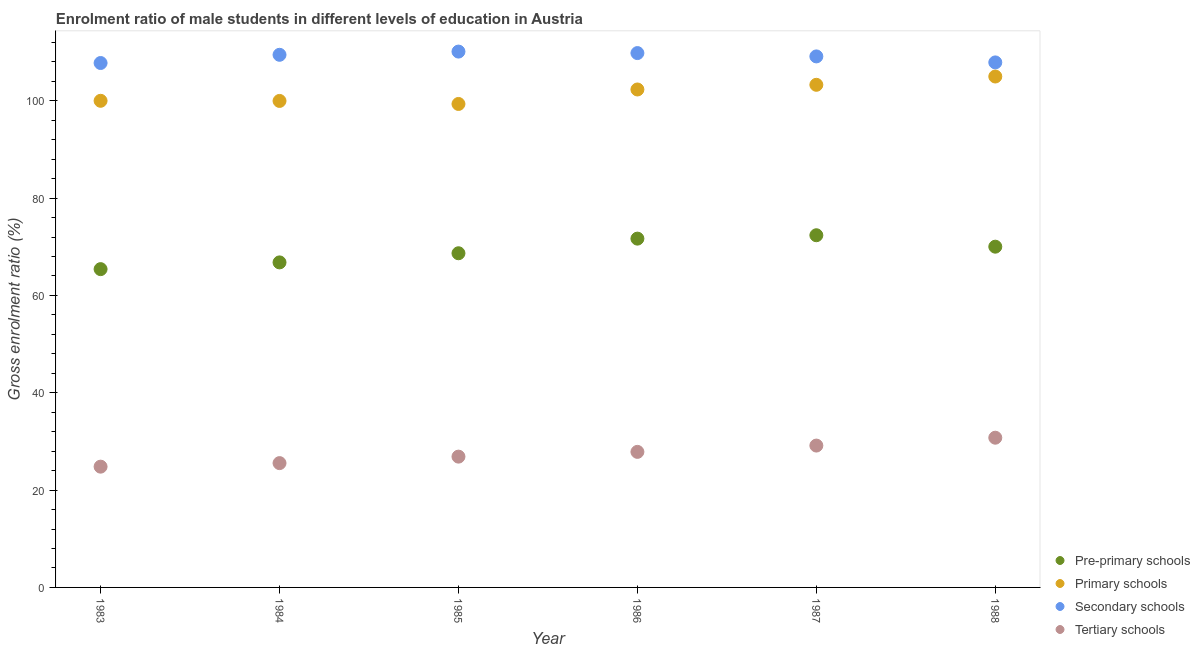What is the gross enrolment ratio(female) in primary schools in 1983?
Make the answer very short. 100. Across all years, what is the maximum gross enrolment ratio(female) in tertiary schools?
Offer a terse response. 30.77. Across all years, what is the minimum gross enrolment ratio(female) in secondary schools?
Your answer should be very brief. 107.77. In which year was the gross enrolment ratio(female) in tertiary schools maximum?
Make the answer very short. 1988. What is the total gross enrolment ratio(female) in tertiary schools in the graph?
Your answer should be very brief. 165.02. What is the difference between the gross enrolment ratio(female) in tertiary schools in 1984 and that in 1986?
Keep it short and to the point. -2.31. What is the difference between the gross enrolment ratio(female) in secondary schools in 1987 and the gross enrolment ratio(female) in primary schools in 1984?
Your response must be concise. 9.15. What is the average gross enrolment ratio(female) in secondary schools per year?
Your answer should be very brief. 109.03. In the year 1983, what is the difference between the gross enrolment ratio(female) in tertiary schools and gross enrolment ratio(female) in primary schools?
Your answer should be very brief. -75.18. In how many years, is the gross enrolment ratio(female) in pre-primary schools greater than 56 %?
Your response must be concise. 6. What is the ratio of the gross enrolment ratio(female) in primary schools in 1986 to that in 1987?
Your answer should be compact. 0.99. What is the difference between the highest and the second highest gross enrolment ratio(female) in primary schools?
Your answer should be compact. 1.7. What is the difference between the highest and the lowest gross enrolment ratio(female) in tertiary schools?
Keep it short and to the point. 5.95. Is the sum of the gross enrolment ratio(female) in primary schools in 1983 and 1988 greater than the maximum gross enrolment ratio(female) in tertiary schools across all years?
Your answer should be compact. Yes. Is it the case that in every year, the sum of the gross enrolment ratio(female) in pre-primary schools and gross enrolment ratio(female) in primary schools is greater than the gross enrolment ratio(female) in secondary schools?
Make the answer very short. Yes. Is the gross enrolment ratio(female) in pre-primary schools strictly less than the gross enrolment ratio(female) in secondary schools over the years?
Your answer should be very brief. Yes. How many years are there in the graph?
Your response must be concise. 6. Are the values on the major ticks of Y-axis written in scientific E-notation?
Offer a very short reply. No. Does the graph contain grids?
Give a very brief answer. No. How many legend labels are there?
Your response must be concise. 4. How are the legend labels stacked?
Offer a terse response. Vertical. What is the title of the graph?
Provide a short and direct response. Enrolment ratio of male students in different levels of education in Austria. What is the label or title of the X-axis?
Offer a very short reply. Year. What is the Gross enrolment ratio (%) in Pre-primary schools in 1983?
Provide a short and direct response. 65.41. What is the Gross enrolment ratio (%) in Primary schools in 1983?
Make the answer very short. 100. What is the Gross enrolment ratio (%) in Secondary schools in 1983?
Provide a short and direct response. 107.77. What is the Gross enrolment ratio (%) in Tertiary schools in 1983?
Your response must be concise. 24.82. What is the Gross enrolment ratio (%) in Pre-primary schools in 1984?
Your answer should be very brief. 66.79. What is the Gross enrolment ratio (%) of Primary schools in 1984?
Your answer should be very brief. 99.97. What is the Gross enrolment ratio (%) of Secondary schools in 1984?
Your answer should be very brief. 109.45. What is the Gross enrolment ratio (%) in Tertiary schools in 1984?
Ensure brevity in your answer.  25.55. What is the Gross enrolment ratio (%) in Pre-primary schools in 1985?
Offer a very short reply. 68.67. What is the Gross enrolment ratio (%) in Primary schools in 1985?
Provide a succinct answer. 99.35. What is the Gross enrolment ratio (%) of Secondary schools in 1985?
Keep it short and to the point. 110.12. What is the Gross enrolment ratio (%) in Tertiary schools in 1985?
Make the answer very short. 26.88. What is the Gross enrolment ratio (%) of Pre-primary schools in 1986?
Make the answer very short. 71.68. What is the Gross enrolment ratio (%) in Primary schools in 1986?
Give a very brief answer. 102.33. What is the Gross enrolment ratio (%) in Secondary schools in 1986?
Offer a very short reply. 109.81. What is the Gross enrolment ratio (%) of Tertiary schools in 1986?
Ensure brevity in your answer.  27.86. What is the Gross enrolment ratio (%) in Pre-primary schools in 1987?
Give a very brief answer. 72.37. What is the Gross enrolment ratio (%) of Primary schools in 1987?
Your response must be concise. 103.29. What is the Gross enrolment ratio (%) of Secondary schools in 1987?
Your response must be concise. 109.12. What is the Gross enrolment ratio (%) in Tertiary schools in 1987?
Offer a very short reply. 29.15. What is the Gross enrolment ratio (%) of Pre-primary schools in 1988?
Provide a short and direct response. 70.02. What is the Gross enrolment ratio (%) in Primary schools in 1988?
Ensure brevity in your answer.  104.99. What is the Gross enrolment ratio (%) in Secondary schools in 1988?
Your answer should be very brief. 107.89. What is the Gross enrolment ratio (%) of Tertiary schools in 1988?
Offer a terse response. 30.77. Across all years, what is the maximum Gross enrolment ratio (%) in Pre-primary schools?
Keep it short and to the point. 72.37. Across all years, what is the maximum Gross enrolment ratio (%) of Primary schools?
Offer a very short reply. 104.99. Across all years, what is the maximum Gross enrolment ratio (%) of Secondary schools?
Your answer should be compact. 110.12. Across all years, what is the maximum Gross enrolment ratio (%) of Tertiary schools?
Make the answer very short. 30.77. Across all years, what is the minimum Gross enrolment ratio (%) of Pre-primary schools?
Make the answer very short. 65.41. Across all years, what is the minimum Gross enrolment ratio (%) of Primary schools?
Your answer should be compact. 99.35. Across all years, what is the minimum Gross enrolment ratio (%) of Secondary schools?
Provide a short and direct response. 107.77. Across all years, what is the minimum Gross enrolment ratio (%) of Tertiary schools?
Provide a succinct answer. 24.82. What is the total Gross enrolment ratio (%) in Pre-primary schools in the graph?
Your answer should be compact. 414.95. What is the total Gross enrolment ratio (%) of Primary schools in the graph?
Keep it short and to the point. 609.93. What is the total Gross enrolment ratio (%) in Secondary schools in the graph?
Offer a very short reply. 654.16. What is the total Gross enrolment ratio (%) in Tertiary schools in the graph?
Make the answer very short. 165.02. What is the difference between the Gross enrolment ratio (%) of Pre-primary schools in 1983 and that in 1984?
Ensure brevity in your answer.  -1.39. What is the difference between the Gross enrolment ratio (%) in Primary schools in 1983 and that in 1984?
Ensure brevity in your answer.  0.03. What is the difference between the Gross enrolment ratio (%) in Secondary schools in 1983 and that in 1984?
Your answer should be compact. -1.69. What is the difference between the Gross enrolment ratio (%) of Tertiary schools in 1983 and that in 1984?
Provide a succinct answer. -0.73. What is the difference between the Gross enrolment ratio (%) in Pre-primary schools in 1983 and that in 1985?
Provide a short and direct response. -3.26. What is the difference between the Gross enrolment ratio (%) in Primary schools in 1983 and that in 1985?
Your answer should be very brief. 0.65. What is the difference between the Gross enrolment ratio (%) of Secondary schools in 1983 and that in 1985?
Provide a short and direct response. -2.35. What is the difference between the Gross enrolment ratio (%) in Tertiary schools in 1983 and that in 1985?
Keep it short and to the point. -2.06. What is the difference between the Gross enrolment ratio (%) of Pre-primary schools in 1983 and that in 1986?
Give a very brief answer. -6.27. What is the difference between the Gross enrolment ratio (%) in Primary schools in 1983 and that in 1986?
Your answer should be compact. -2.33. What is the difference between the Gross enrolment ratio (%) of Secondary schools in 1983 and that in 1986?
Offer a very short reply. -2.04. What is the difference between the Gross enrolment ratio (%) of Tertiary schools in 1983 and that in 1986?
Keep it short and to the point. -3.04. What is the difference between the Gross enrolment ratio (%) in Pre-primary schools in 1983 and that in 1987?
Ensure brevity in your answer.  -6.96. What is the difference between the Gross enrolment ratio (%) of Primary schools in 1983 and that in 1987?
Make the answer very short. -3.29. What is the difference between the Gross enrolment ratio (%) of Secondary schools in 1983 and that in 1987?
Offer a terse response. -1.36. What is the difference between the Gross enrolment ratio (%) in Tertiary schools in 1983 and that in 1987?
Give a very brief answer. -4.33. What is the difference between the Gross enrolment ratio (%) of Pre-primary schools in 1983 and that in 1988?
Keep it short and to the point. -4.61. What is the difference between the Gross enrolment ratio (%) in Primary schools in 1983 and that in 1988?
Provide a short and direct response. -4.99. What is the difference between the Gross enrolment ratio (%) in Secondary schools in 1983 and that in 1988?
Offer a very short reply. -0.12. What is the difference between the Gross enrolment ratio (%) in Tertiary schools in 1983 and that in 1988?
Give a very brief answer. -5.95. What is the difference between the Gross enrolment ratio (%) in Pre-primary schools in 1984 and that in 1985?
Your response must be concise. -1.88. What is the difference between the Gross enrolment ratio (%) of Primary schools in 1984 and that in 1985?
Provide a short and direct response. 0.62. What is the difference between the Gross enrolment ratio (%) in Secondary schools in 1984 and that in 1985?
Your answer should be very brief. -0.66. What is the difference between the Gross enrolment ratio (%) in Tertiary schools in 1984 and that in 1985?
Provide a succinct answer. -1.33. What is the difference between the Gross enrolment ratio (%) of Pre-primary schools in 1984 and that in 1986?
Offer a terse response. -4.88. What is the difference between the Gross enrolment ratio (%) in Primary schools in 1984 and that in 1986?
Your answer should be very brief. -2.35. What is the difference between the Gross enrolment ratio (%) in Secondary schools in 1984 and that in 1986?
Make the answer very short. -0.35. What is the difference between the Gross enrolment ratio (%) in Tertiary schools in 1984 and that in 1986?
Your response must be concise. -2.31. What is the difference between the Gross enrolment ratio (%) of Pre-primary schools in 1984 and that in 1987?
Your response must be concise. -5.58. What is the difference between the Gross enrolment ratio (%) in Primary schools in 1984 and that in 1987?
Your answer should be very brief. -3.31. What is the difference between the Gross enrolment ratio (%) of Secondary schools in 1984 and that in 1987?
Provide a succinct answer. 0.33. What is the difference between the Gross enrolment ratio (%) of Tertiary schools in 1984 and that in 1987?
Offer a very short reply. -3.6. What is the difference between the Gross enrolment ratio (%) of Pre-primary schools in 1984 and that in 1988?
Ensure brevity in your answer.  -3.23. What is the difference between the Gross enrolment ratio (%) of Primary schools in 1984 and that in 1988?
Provide a short and direct response. -5.02. What is the difference between the Gross enrolment ratio (%) of Secondary schools in 1984 and that in 1988?
Your response must be concise. 1.56. What is the difference between the Gross enrolment ratio (%) of Tertiary schools in 1984 and that in 1988?
Your answer should be very brief. -5.22. What is the difference between the Gross enrolment ratio (%) of Pre-primary schools in 1985 and that in 1986?
Ensure brevity in your answer.  -3. What is the difference between the Gross enrolment ratio (%) in Primary schools in 1985 and that in 1986?
Give a very brief answer. -2.97. What is the difference between the Gross enrolment ratio (%) in Secondary schools in 1985 and that in 1986?
Provide a short and direct response. 0.31. What is the difference between the Gross enrolment ratio (%) in Tertiary schools in 1985 and that in 1986?
Keep it short and to the point. -0.98. What is the difference between the Gross enrolment ratio (%) in Pre-primary schools in 1985 and that in 1987?
Keep it short and to the point. -3.7. What is the difference between the Gross enrolment ratio (%) of Primary schools in 1985 and that in 1987?
Offer a terse response. -3.94. What is the difference between the Gross enrolment ratio (%) of Tertiary schools in 1985 and that in 1987?
Offer a very short reply. -2.27. What is the difference between the Gross enrolment ratio (%) in Pre-primary schools in 1985 and that in 1988?
Provide a succinct answer. -1.35. What is the difference between the Gross enrolment ratio (%) in Primary schools in 1985 and that in 1988?
Offer a very short reply. -5.64. What is the difference between the Gross enrolment ratio (%) in Secondary schools in 1985 and that in 1988?
Ensure brevity in your answer.  2.23. What is the difference between the Gross enrolment ratio (%) of Tertiary schools in 1985 and that in 1988?
Provide a succinct answer. -3.89. What is the difference between the Gross enrolment ratio (%) of Pre-primary schools in 1986 and that in 1987?
Offer a very short reply. -0.7. What is the difference between the Gross enrolment ratio (%) of Primary schools in 1986 and that in 1987?
Ensure brevity in your answer.  -0.96. What is the difference between the Gross enrolment ratio (%) in Secondary schools in 1986 and that in 1987?
Provide a succinct answer. 0.68. What is the difference between the Gross enrolment ratio (%) in Tertiary schools in 1986 and that in 1987?
Provide a short and direct response. -1.3. What is the difference between the Gross enrolment ratio (%) in Pre-primary schools in 1986 and that in 1988?
Your answer should be very brief. 1.65. What is the difference between the Gross enrolment ratio (%) of Primary schools in 1986 and that in 1988?
Your answer should be very brief. -2.67. What is the difference between the Gross enrolment ratio (%) of Secondary schools in 1986 and that in 1988?
Offer a very short reply. 1.92. What is the difference between the Gross enrolment ratio (%) in Tertiary schools in 1986 and that in 1988?
Your answer should be compact. -2.91. What is the difference between the Gross enrolment ratio (%) of Pre-primary schools in 1987 and that in 1988?
Offer a very short reply. 2.35. What is the difference between the Gross enrolment ratio (%) of Primary schools in 1987 and that in 1988?
Ensure brevity in your answer.  -1.7. What is the difference between the Gross enrolment ratio (%) of Secondary schools in 1987 and that in 1988?
Keep it short and to the point. 1.23. What is the difference between the Gross enrolment ratio (%) of Tertiary schools in 1987 and that in 1988?
Offer a very short reply. -1.62. What is the difference between the Gross enrolment ratio (%) of Pre-primary schools in 1983 and the Gross enrolment ratio (%) of Primary schools in 1984?
Ensure brevity in your answer.  -34.56. What is the difference between the Gross enrolment ratio (%) in Pre-primary schools in 1983 and the Gross enrolment ratio (%) in Secondary schools in 1984?
Your answer should be very brief. -44.05. What is the difference between the Gross enrolment ratio (%) in Pre-primary schools in 1983 and the Gross enrolment ratio (%) in Tertiary schools in 1984?
Provide a succinct answer. 39.86. What is the difference between the Gross enrolment ratio (%) of Primary schools in 1983 and the Gross enrolment ratio (%) of Secondary schools in 1984?
Your response must be concise. -9.45. What is the difference between the Gross enrolment ratio (%) in Primary schools in 1983 and the Gross enrolment ratio (%) in Tertiary schools in 1984?
Provide a short and direct response. 74.45. What is the difference between the Gross enrolment ratio (%) in Secondary schools in 1983 and the Gross enrolment ratio (%) in Tertiary schools in 1984?
Offer a very short reply. 82.22. What is the difference between the Gross enrolment ratio (%) of Pre-primary schools in 1983 and the Gross enrolment ratio (%) of Primary schools in 1985?
Your answer should be very brief. -33.94. What is the difference between the Gross enrolment ratio (%) in Pre-primary schools in 1983 and the Gross enrolment ratio (%) in Secondary schools in 1985?
Provide a short and direct response. -44.71. What is the difference between the Gross enrolment ratio (%) of Pre-primary schools in 1983 and the Gross enrolment ratio (%) of Tertiary schools in 1985?
Provide a short and direct response. 38.53. What is the difference between the Gross enrolment ratio (%) of Primary schools in 1983 and the Gross enrolment ratio (%) of Secondary schools in 1985?
Ensure brevity in your answer.  -10.11. What is the difference between the Gross enrolment ratio (%) of Primary schools in 1983 and the Gross enrolment ratio (%) of Tertiary schools in 1985?
Your response must be concise. 73.12. What is the difference between the Gross enrolment ratio (%) of Secondary schools in 1983 and the Gross enrolment ratio (%) of Tertiary schools in 1985?
Offer a terse response. 80.89. What is the difference between the Gross enrolment ratio (%) in Pre-primary schools in 1983 and the Gross enrolment ratio (%) in Primary schools in 1986?
Your response must be concise. -36.92. What is the difference between the Gross enrolment ratio (%) of Pre-primary schools in 1983 and the Gross enrolment ratio (%) of Secondary schools in 1986?
Your response must be concise. -44.4. What is the difference between the Gross enrolment ratio (%) of Pre-primary schools in 1983 and the Gross enrolment ratio (%) of Tertiary schools in 1986?
Your answer should be very brief. 37.55. What is the difference between the Gross enrolment ratio (%) in Primary schools in 1983 and the Gross enrolment ratio (%) in Secondary schools in 1986?
Your response must be concise. -9.81. What is the difference between the Gross enrolment ratio (%) of Primary schools in 1983 and the Gross enrolment ratio (%) of Tertiary schools in 1986?
Provide a succinct answer. 72.15. What is the difference between the Gross enrolment ratio (%) of Secondary schools in 1983 and the Gross enrolment ratio (%) of Tertiary schools in 1986?
Give a very brief answer. 79.91. What is the difference between the Gross enrolment ratio (%) in Pre-primary schools in 1983 and the Gross enrolment ratio (%) in Primary schools in 1987?
Keep it short and to the point. -37.88. What is the difference between the Gross enrolment ratio (%) of Pre-primary schools in 1983 and the Gross enrolment ratio (%) of Secondary schools in 1987?
Offer a terse response. -43.71. What is the difference between the Gross enrolment ratio (%) of Pre-primary schools in 1983 and the Gross enrolment ratio (%) of Tertiary schools in 1987?
Ensure brevity in your answer.  36.26. What is the difference between the Gross enrolment ratio (%) in Primary schools in 1983 and the Gross enrolment ratio (%) in Secondary schools in 1987?
Keep it short and to the point. -9.12. What is the difference between the Gross enrolment ratio (%) in Primary schools in 1983 and the Gross enrolment ratio (%) in Tertiary schools in 1987?
Provide a short and direct response. 70.85. What is the difference between the Gross enrolment ratio (%) of Secondary schools in 1983 and the Gross enrolment ratio (%) of Tertiary schools in 1987?
Your answer should be compact. 78.62. What is the difference between the Gross enrolment ratio (%) of Pre-primary schools in 1983 and the Gross enrolment ratio (%) of Primary schools in 1988?
Keep it short and to the point. -39.58. What is the difference between the Gross enrolment ratio (%) in Pre-primary schools in 1983 and the Gross enrolment ratio (%) in Secondary schools in 1988?
Your answer should be very brief. -42.48. What is the difference between the Gross enrolment ratio (%) of Pre-primary schools in 1983 and the Gross enrolment ratio (%) of Tertiary schools in 1988?
Provide a succinct answer. 34.64. What is the difference between the Gross enrolment ratio (%) of Primary schools in 1983 and the Gross enrolment ratio (%) of Secondary schools in 1988?
Ensure brevity in your answer.  -7.89. What is the difference between the Gross enrolment ratio (%) in Primary schools in 1983 and the Gross enrolment ratio (%) in Tertiary schools in 1988?
Offer a terse response. 69.23. What is the difference between the Gross enrolment ratio (%) in Secondary schools in 1983 and the Gross enrolment ratio (%) in Tertiary schools in 1988?
Your answer should be compact. 77. What is the difference between the Gross enrolment ratio (%) of Pre-primary schools in 1984 and the Gross enrolment ratio (%) of Primary schools in 1985?
Make the answer very short. -32.56. What is the difference between the Gross enrolment ratio (%) in Pre-primary schools in 1984 and the Gross enrolment ratio (%) in Secondary schools in 1985?
Your response must be concise. -43.32. What is the difference between the Gross enrolment ratio (%) in Pre-primary schools in 1984 and the Gross enrolment ratio (%) in Tertiary schools in 1985?
Your answer should be very brief. 39.92. What is the difference between the Gross enrolment ratio (%) in Primary schools in 1984 and the Gross enrolment ratio (%) in Secondary schools in 1985?
Offer a very short reply. -10.14. What is the difference between the Gross enrolment ratio (%) in Primary schools in 1984 and the Gross enrolment ratio (%) in Tertiary schools in 1985?
Your answer should be very brief. 73.09. What is the difference between the Gross enrolment ratio (%) of Secondary schools in 1984 and the Gross enrolment ratio (%) of Tertiary schools in 1985?
Your response must be concise. 82.58. What is the difference between the Gross enrolment ratio (%) in Pre-primary schools in 1984 and the Gross enrolment ratio (%) in Primary schools in 1986?
Make the answer very short. -35.53. What is the difference between the Gross enrolment ratio (%) in Pre-primary schools in 1984 and the Gross enrolment ratio (%) in Secondary schools in 1986?
Ensure brevity in your answer.  -43.01. What is the difference between the Gross enrolment ratio (%) in Pre-primary schools in 1984 and the Gross enrolment ratio (%) in Tertiary schools in 1986?
Offer a very short reply. 38.94. What is the difference between the Gross enrolment ratio (%) in Primary schools in 1984 and the Gross enrolment ratio (%) in Secondary schools in 1986?
Provide a short and direct response. -9.84. What is the difference between the Gross enrolment ratio (%) in Primary schools in 1984 and the Gross enrolment ratio (%) in Tertiary schools in 1986?
Provide a succinct answer. 72.12. What is the difference between the Gross enrolment ratio (%) of Secondary schools in 1984 and the Gross enrolment ratio (%) of Tertiary schools in 1986?
Make the answer very short. 81.6. What is the difference between the Gross enrolment ratio (%) in Pre-primary schools in 1984 and the Gross enrolment ratio (%) in Primary schools in 1987?
Ensure brevity in your answer.  -36.49. What is the difference between the Gross enrolment ratio (%) in Pre-primary schools in 1984 and the Gross enrolment ratio (%) in Secondary schools in 1987?
Offer a terse response. -42.33. What is the difference between the Gross enrolment ratio (%) of Pre-primary schools in 1984 and the Gross enrolment ratio (%) of Tertiary schools in 1987?
Provide a short and direct response. 37.64. What is the difference between the Gross enrolment ratio (%) of Primary schools in 1984 and the Gross enrolment ratio (%) of Secondary schools in 1987?
Provide a short and direct response. -9.15. What is the difference between the Gross enrolment ratio (%) of Primary schools in 1984 and the Gross enrolment ratio (%) of Tertiary schools in 1987?
Make the answer very short. 70.82. What is the difference between the Gross enrolment ratio (%) of Secondary schools in 1984 and the Gross enrolment ratio (%) of Tertiary schools in 1987?
Provide a short and direct response. 80.3. What is the difference between the Gross enrolment ratio (%) in Pre-primary schools in 1984 and the Gross enrolment ratio (%) in Primary schools in 1988?
Offer a very short reply. -38.2. What is the difference between the Gross enrolment ratio (%) in Pre-primary schools in 1984 and the Gross enrolment ratio (%) in Secondary schools in 1988?
Your response must be concise. -41.1. What is the difference between the Gross enrolment ratio (%) of Pre-primary schools in 1984 and the Gross enrolment ratio (%) of Tertiary schools in 1988?
Your answer should be compact. 36.03. What is the difference between the Gross enrolment ratio (%) of Primary schools in 1984 and the Gross enrolment ratio (%) of Secondary schools in 1988?
Your answer should be very brief. -7.92. What is the difference between the Gross enrolment ratio (%) of Primary schools in 1984 and the Gross enrolment ratio (%) of Tertiary schools in 1988?
Give a very brief answer. 69.21. What is the difference between the Gross enrolment ratio (%) of Secondary schools in 1984 and the Gross enrolment ratio (%) of Tertiary schools in 1988?
Offer a very short reply. 78.69. What is the difference between the Gross enrolment ratio (%) of Pre-primary schools in 1985 and the Gross enrolment ratio (%) of Primary schools in 1986?
Ensure brevity in your answer.  -33.65. What is the difference between the Gross enrolment ratio (%) of Pre-primary schools in 1985 and the Gross enrolment ratio (%) of Secondary schools in 1986?
Your answer should be compact. -41.14. What is the difference between the Gross enrolment ratio (%) in Pre-primary schools in 1985 and the Gross enrolment ratio (%) in Tertiary schools in 1986?
Your answer should be compact. 40.82. What is the difference between the Gross enrolment ratio (%) in Primary schools in 1985 and the Gross enrolment ratio (%) in Secondary schools in 1986?
Provide a succinct answer. -10.46. What is the difference between the Gross enrolment ratio (%) of Primary schools in 1985 and the Gross enrolment ratio (%) of Tertiary schools in 1986?
Your answer should be very brief. 71.5. What is the difference between the Gross enrolment ratio (%) in Secondary schools in 1985 and the Gross enrolment ratio (%) in Tertiary schools in 1986?
Keep it short and to the point. 82.26. What is the difference between the Gross enrolment ratio (%) in Pre-primary schools in 1985 and the Gross enrolment ratio (%) in Primary schools in 1987?
Offer a terse response. -34.62. What is the difference between the Gross enrolment ratio (%) in Pre-primary schools in 1985 and the Gross enrolment ratio (%) in Secondary schools in 1987?
Your response must be concise. -40.45. What is the difference between the Gross enrolment ratio (%) of Pre-primary schools in 1985 and the Gross enrolment ratio (%) of Tertiary schools in 1987?
Your response must be concise. 39.52. What is the difference between the Gross enrolment ratio (%) in Primary schools in 1985 and the Gross enrolment ratio (%) in Secondary schools in 1987?
Give a very brief answer. -9.77. What is the difference between the Gross enrolment ratio (%) in Primary schools in 1985 and the Gross enrolment ratio (%) in Tertiary schools in 1987?
Provide a succinct answer. 70.2. What is the difference between the Gross enrolment ratio (%) in Secondary schools in 1985 and the Gross enrolment ratio (%) in Tertiary schools in 1987?
Your answer should be compact. 80.96. What is the difference between the Gross enrolment ratio (%) in Pre-primary schools in 1985 and the Gross enrolment ratio (%) in Primary schools in 1988?
Provide a succinct answer. -36.32. What is the difference between the Gross enrolment ratio (%) in Pre-primary schools in 1985 and the Gross enrolment ratio (%) in Secondary schools in 1988?
Your answer should be very brief. -39.22. What is the difference between the Gross enrolment ratio (%) in Pre-primary schools in 1985 and the Gross enrolment ratio (%) in Tertiary schools in 1988?
Give a very brief answer. 37.91. What is the difference between the Gross enrolment ratio (%) of Primary schools in 1985 and the Gross enrolment ratio (%) of Secondary schools in 1988?
Offer a terse response. -8.54. What is the difference between the Gross enrolment ratio (%) of Primary schools in 1985 and the Gross enrolment ratio (%) of Tertiary schools in 1988?
Your answer should be very brief. 68.59. What is the difference between the Gross enrolment ratio (%) of Secondary schools in 1985 and the Gross enrolment ratio (%) of Tertiary schools in 1988?
Give a very brief answer. 79.35. What is the difference between the Gross enrolment ratio (%) in Pre-primary schools in 1986 and the Gross enrolment ratio (%) in Primary schools in 1987?
Give a very brief answer. -31.61. What is the difference between the Gross enrolment ratio (%) in Pre-primary schools in 1986 and the Gross enrolment ratio (%) in Secondary schools in 1987?
Make the answer very short. -37.45. What is the difference between the Gross enrolment ratio (%) in Pre-primary schools in 1986 and the Gross enrolment ratio (%) in Tertiary schools in 1987?
Give a very brief answer. 42.53. What is the difference between the Gross enrolment ratio (%) of Primary schools in 1986 and the Gross enrolment ratio (%) of Secondary schools in 1987?
Your answer should be very brief. -6.8. What is the difference between the Gross enrolment ratio (%) in Primary schools in 1986 and the Gross enrolment ratio (%) in Tertiary schools in 1987?
Make the answer very short. 73.18. What is the difference between the Gross enrolment ratio (%) of Secondary schools in 1986 and the Gross enrolment ratio (%) of Tertiary schools in 1987?
Ensure brevity in your answer.  80.66. What is the difference between the Gross enrolment ratio (%) in Pre-primary schools in 1986 and the Gross enrolment ratio (%) in Primary schools in 1988?
Provide a succinct answer. -33.31. What is the difference between the Gross enrolment ratio (%) of Pre-primary schools in 1986 and the Gross enrolment ratio (%) of Secondary schools in 1988?
Your response must be concise. -36.21. What is the difference between the Gross enrolment ratio (%) in Pre-primary schools in 1986 and the Gross enrolment ratio (%) in Tertiary schools in 1988?
Provide a short and direct response. 40.91. What is the difference between the Gross enrolment ratio (%) of Primary schools in 1986 and the Gross enrolment ratio (%) of Secondary schools in 1988?
Provide a succinct answer. -5.56. What is the difference between the Gross enrolment ratio (%) of Primary schools in 1986 and the Gross enrolment ratio (%) of Tertiary schools in 1988?
Ensure brevity in your answer.  71.56. What is the difference between the Gross enrolment ratio (%) in Secondary schools in 1986 and the Gross enrolment ratio (%) in Tertiary schools in 1988?
Your response must be concise. 79.04. What is the difference between the Gross enrolment ratio (%) in Pre-primary schools in 1987 and the Gross enrolment ratio (%) in Primary schools in 1988?
Offer a very short reply. -32.62. What is the difference between the Gross enrolment ratio (%) in Pre-primary schools in 1987 and the Gross enrolment ratio (%) in Secondary schools in 1988?
Provide a short and direct response. -35.52. What is the difference between the Gross enrolment ratio (%) of Pre-primary schools in 1987 and the Gross enrolment ratio (%) of Tertiary schools in 1988?
Provide a short and direct response. 41.61. What is the difference between the Gross enrolment ratio (%) of Primary schools in 1987 and the Gross enrolment ratio (%) of Secondary schools in 1988?
Provide a succinct answer. -4.6. What is the difference between the Gross enrolment ratio (%) of Primary schools in 1987 and the Gross enrolment ratio (%) of Tertiary schools in 1988?
Keep it short and to the point. 72.52. What is the difference between the Gross enrolment ratio (%) in Secondary schools in 1987 and the Gross enrolment ratio (%) in Tertiary schools in 1988?
Your answer should be compact. 78.36. What is the average Gross enrolment ratio (%) in Pre-primary schools per year?
Ensure brevity in your answer.  69.16. What is the average Gross enrolment ratio (%) in Primary schools per year?
Make the answer very short. 101.66. What is the average Gross enrolment ratio (%) in Secondary schools per year?
Your response must be concise. 109.03. What is the average Gross enrolment ratio (%) in Tertiary schools per year?
Make the answer very short. 27.5. In the year 1983, what is the difference between the Gross enrolment ratio (%) of Pre-primary schools and Gross enrolment ratio (%) of Primary schools?
Provide a succinct answer. -34.59. In the year 1983, what is the difference between the Gross enrolment ratio (%) in Pre-primary schools and Gross enrolment ratio (%) in Secondary schools?
Provide a short and direct response. -42.36. In the year 1983, what is the difference between the Gross enrolment ratio (%) of Pre-primary schools and Gross enrolment ratio (%) of Tertiary schools?
Give a very brief answer. 40.59. In the year 1983, what is the difference between the Gross enrolment ratio (%) in Primary schools and Gross enrolment ratio (%) in Secondary schools?
Keep it short and to the point. -7.77. In the year 1983, what is the difference between the Gross enrolment ratio (%) in Primary schools and Gross enrolment ratio (%) in Tertiary schools?
Your response must be concise. 75.18. In the year 1983, what is the difference between the Gross enrolment ratio (%) of Secondary schools and Gross enrolment ratio (%) of Tertiary schools?
Keep it short and to the point. 82.95. In the year 1984, what is the difference between the Gross enrolment ratio (%) in Pre-primary schools and Gross enrolment ratio (%) in Primary schools?
Offer a very short reply. -33.18. In the year 1984, what is the difference between the Gross enrolment ratio (%) in Pre-primary schools and Gross enrolment ratio (%) in Secondary schools?
Offer a very short reply. -42.66. In the year 1984, what is the difference between the Gross enrolment ratio (%) in Pre-primary schools and Gross enrolment ratio (%) in Tertiary schools?
Your answer should be very brief. 41.25. In the year 1984, what is the difference between the Gross enrolment ratio (%) of Primary schools and Gross enrolment ratio (%) of Secondary schools?
Your answer should be very brief. -9.48. In the year 1984, what is the difference between the Gross enrolment ratio (%) of Primary schools and Gross enrolment ratio (%) of Tertiary schools?
Ensure brevity in your answer.  74.43. In the year 1984, what is the difference between the Gross enrolment ratio (%) in Secondary schools and Gross enrolment ratio (%) in Tertiary schools?
Your response must be concise. 83.91. In the year 1985, what is the difference between the Gross enrolment ratio (%) in Pre-primary schools and Gross enrolment ratio (%) in Primary schools?
Your response must be concise. -30.68. In the year 1985, what is the difference between the Gross enrolment ratio (%) in Pre-primary schools and Gross enrolment ratio (%) in Secondary schools?
Offer a terse response. -41.44. In the year 1985, what is the difference between the Gross enrolment ratio (%) in Pre-primary schools and Gross enrolment ratio (%) in Tertiary schools?
Your answer should be compact. 41.79. In the year 1985, what is the difference between the Gross enrolment ratio (%) in Primary schools and Gross enrolment ratio (%) in Secondary schools?
Your answer should be compact. -10.76. In the year 1985, what is the difference between the Gross enrolment ratio (%) in Primary schools and Gross enrolment ratio (%) in Tertiary schools?
Offer a very short reply. 72.47. In the year 1985, what is the difference between the Gross enrolment ratio (%) of Secondary schools and Gross enrolment ratio (%) of Tertiary schools?
Give a very brief answer. 83.24. In the year 1986, what is the difference between the Gross enrolment ratio (%) of Pre-primary schools and Gross enrolment ratio (%) of Primary schools?
Provide a succinct answer. -30.65. In the year 1986, what is the difference between the Gross enrolment ratio (%) in Pre-primary schools and Gross enrolment ratio (%) in Secondary schools?
Offer a terse response. -38.13. In the year 1986, what is the difference between the Gross enrolment ratio (%) in Pre-primary schools and Gross enrolment ratio (%) in Tertiary schools?
Provide a short and direct response. 43.82. In the year 1986, what is the difference between the Gross enrolment ratio (%) in Primary schools and Gross enrolment ratio (%) in Secondary schools?
Your answer should be very brief. -7.48. In the year 1986, what is the difference between the Gross enrolment ratio (%) of Primary schools and Gross enrolment ratio (%) of Tertiary schools?
Offer a very short reply. 74.47. In the year 1986, what is the difference between the Gross enrolment ratio (%) of Secondary schools and Gross enrolment ratio (%) of Tertiary schools?
Provide a succinct answer. 81.95. In the year 1987, what is the difference between the Gross enrolment ratio (%) in Pre-primary schools and Gross enrolment ratio (%) in Primary schools?
Your answer should be compact. -30.91. In the year 1987, what is the difference between the Gross enrolment ratio (%) in Pre-primary schools and Gross enrolment ratio (%) in Secondary schools?
Keep it short and to the point. -36.75. In the year 1987, what is the difference between the Gross enrolment ratio (%) of Pre-primary schools and Gross enrolment ratio (%) of Tertiary schools?
Make the answer very short. 43.22. In the year 1987, what is the difference between the Gross enrolment ratio (%) of Primary schools and Gross enrolment ratio (%) of Secondary schools?
Make the answer very short. -5.84. In the year 1987, what is the difference between the Gross enrolment ratio (%) of Primary schools and Gross enrolment ratio (%) of Tertiary schools?
Keep it short and to the point. 74.14. In the year 1987, what is the difference between the Gross enrolment ratio (%) of Secondary schools and Gross enrolment ratio (%) of Tertiary schools?
Give a very brief answer. 79.97. In the year 1988, what is the difference between the Gross enrolment ratio (%) in Pre-primary schools and Gross enrolment ratio (%) in Primary schools?
Offer a very short reply. -34.97. In the year 1988, what is the difference between the Gross enrolment ratio (%) in Pre-primary schools and Gross enrolment ratio (%) in Secondary schools?
Provide a short and direct response. -37.87. In the year 1988, what is the difference between the Gross enrolment ratio (%) in Pre-primary schools and Gross enrolment ratio (%) in Tertiary schools?
Your answer should be compact. 39.26. In the year 1988, what is the difference between the Gross enrolment ratio (%) in Primary schools and Gross enrolment ratio (%) in Secondary schools?
Provide a short and direct response. -2.9. In the year 1988, what is the difference between the Gross enrolment ratio (%) in Primary schools and Gross enrolment ratio (%) in Tertiary schools?
Offer a very short reply. 74.23. In the year 1988, what is the difference between the Gross enrolment ratio (%) in Secondary schools and Gross enrolment ratio (%) in Tertiary schools?
Offer a very short reply. 77.12. What is the ratio of the Gross enrolment ratio (%) of Pre-primary schools in 1983 to that in 1984?
Give a very brief answer. 0.98. What is the ratio of the Gross enrolment ratio (%) of Secondary schools in 1983 to that in 1984?
Ensure brevity in your answer.  0.98. What is the ratio of the Gross enrolment ratio (%) in Tertiary schools in 1983 to that in 1984?
Your response must be concise. 0.97. What is the ratio of the Gross enrolment ratio (%) in Pre-primary schools in 1983 to that in 1985?
Your answer should be compact. 0.95. What is the ratio of the Gross enrolment ratio (%) of Secondary schools in 1983 to that in 1985?
Your answer should be very brief. 0.98. What is the ratio of the Gross enrolment ratio (%) of Tertiary schools in 1983 to that in 1985?
Your answer should be very brief. 0.92. What is the ratio of the Gross enrolment ratio (%) of Pre-primary schools in 1983 to that in 1986?
Provide a succinct answer. 0.91. What is the ratio of the Gross enrolment ratio (%) of Primary schools in 1983 to that in 1986?
Offer a very short reply. 0.98. What is the ratio of the Gross enrolment ratio (%) of Secondary schools in 1983 to that in 1986?
Offer a terse response. 0.98. What is the ratio of the Gross enrolment ratio (%) in Tertiary schools in 1983 to that in 1986?
Your answer should be very brief. 0.89. What is the ratio of the Gross enrolment ratio (%) in Pre-primary schools in 1983 to that in 1987?
Your answer should be compact. 0.9. What is the ratio of the Gross enrolment ratio (%) of Primary schools in 1983 to that in 1987?
Your response must be concise. 0.97. What is the ratio of the Gross enrolment ratio (%) of Secondary schools in 1983 to that in 1987?
Your answer should be compact. 0.99. What is the ratio of the Gross enrolment ratio (%) in Tertiary schools in 1983 to that in 1987?
Ensure brevity in your answer.  0.85. What is the ratio of the Gross enrolment ratio (%) of Pre-primary schools in 1983 to that in 1988?
Make the answer very short. 0.93. What is the ratio of the Gross enrolment ratio (%) in Primary schools in 1983 to that in 1988?
Offer a very short reply. 0.95. What is the ratio of the Gross enrolment ratio (%) of Tertiary schools in 1983 to that in 1988?
Your response must be concise. 0.81. What is the ratio of the Gross enrolment ratio (%) in Pre-primary schools in 1984 to that in 1985?
Keep it short and to the point. 0.97. What is the ratio of the Gross enrolment ratio (%) of Primary schools in 1984 to that in 1985?
Ensure brevity in your answer.  1.01. What is the ratio of the Gross enrolment ratio (%) of Secondary schools in 1984 to that in 1985?
Offer a terse response. 0.99. What is the ratio of the Gross enrolment ratio (%) in Tertiary schools in 1984 to that in 1985?
Provide a succinct answer. 0.95. What is the ratio of the Gross enrolment ratio (%) of Pre-primary schools in 1984 to that in 1986?
Ensure brevity in your answer.  0.93. What is the ratio of the Gross enrolment ratio (%) of Secondary schools in 1984 to that in 1986?
Provide a succinct answer. 1. What is the ratio of the Gross enrolment ratio (%) in Tertiary schools in 1984 to that in 1986?
Offer a terse response. 0.92. What is the ratio of the Gross enrolment ratio (%) in Pre-primary schools in 1984 to that in 1987?
Ensure brevity in your answer.  0.92. What is the ratio of the Gross enrolment ratio (%) in Primary schools in 1984 to that in 1987?
Ensure brevity in your answer.  0.97. What is the ratio of the Gross enrolment ratio (%) in Tertiary schools in 1984 to that in 1987?
Offer a very short reply. 0.88. What is the ratio of the Gross enrolment ratio (%) in Pre-primary schools in 1984 to that in 1988?
Provide a succinct answer. 0.95. What is the ratio of the Gross enrolment ratio (%) of Primary schools in 1984 to that in 1988?
Give a very brief answer. 0.95. What is the ratio of the Gross enrolment ratio (%) in Secondary schools in 1984 to that in 1988?
Provide a short and direct response. 1.01. What is the ratio of the Gross enrolment ratio (%) of Tertiary schools in 1984 to that in 1988?
Offer a very short reply. 0.83. What is the ratio of the Gross enrolment ratio (%) in Pre-primary schools in 1985 to that in 1986?
Make the answer very short. 0.96. What is the ratio of the Gross enrolment ratio (%) of Primary schools in 1985 to that in 1986?
Offer a terse response. 0.97. What is the ratio of the Gross enrolment ratio (%) in Secondary schools in 1985 to that in 1986?
Give a very brief answer. 1. What is the ratio of the Gross enrolment ratio (%) of Tertiary schools in 1985 to that in 1986?
Provide a succinct answer. 0.96. What is the ratio of the Gross enrolment ratio (%) in Pre-primary schools in 1985 to that in 1987?
Provide a succinct answer. 0.95. What is the ratio of the Gross enrolment ratio (%) of Primary schools in 1985 to that in 1987?
Your answer should be very brief. 0.96. What is the ratio of the Gross enrolment ratio (%) of Secondary schools in 1985 to that in 1987?
Your answer should be compact. 1.01. What is the ratio of the Gross enrolment ratio (%) in Tertiary schools in 1985 to that in 1987?
Ensure brevity in your answer.  0.92. What is the ratio of the Gross enrolment ratio (%) of Pre-primary schools in 1985 to that in 1988?
Your response must be concise. 0.98. What is the ratio of the Gross enrolment ratio (%) of Primary schools in 1985 to that in 1988?
Your answer should be very brief. 0.95. What is the ratio of the Gross enrolment ratio (%) of Secondary schools in 1985 to that in 1988?
Ensure brevity in your answer.  1.02. What is the ratio of the Gross enrolment ratio (%) in Tertiary schools in 1985 to that in 1988?
Ensure brevity in your answer.  0.87. What is the ratio of the Gross enrolment ratio (%) in Secondary schools in 1986 to that in 1987?
Your answer should be compact. 1.01. What is the ratio of the Gross enrolment ratio (%) of Tertiary schools in 1986 to that in 1987?
Ensure brevity in your answer.  0.96. What is the ratio of the Gross enrolment ratio (%) in Pre-primary schools in 1986 to that in 1988?
Your answer should be compact. 1.02. What is the ratio of the Gross enrolment ratio (%) in Primary schools in 1986 to that in 1988?
Offer a very short reply. 0.97. What is the ratio of the Gross enrolment ratio (%) in Secondary schools in 1986 to that in 1988?
Your answer should be compact. 1.02. What is the ratio of the Gross enrolment ratio (%) of Tertiary schools in 1986 to that in 1988?
Offer a terse response. 0.91. What is the ratio of the Gross enrolment ratio (%) in Pre-primary schools in 1987 to that in 1988?
Your answer should be very brief. 1.03. What is the ratio of the Gross enrolment ratio (%) of Primary schools in 1987 to that in 1988?
Your answer should be very brief. 0.98. What is the ratio of the Gross enrolment ratio (%) of Secondary schools in 1987 to that in 1988?
Provide a short and direct response. 1.01. What is the ratio of the Gross enrolment ratio (%) of Tertiary schools in 1987 to that in 1988?
Keep it short and to the point. 0.95. What is the difference between the highest and the second highest Gross enrolment ratio (%) in Pre-primary schools?
Keep it short and to the point. 0.7. What is the difference between the highest and the second highest Gross enrolment ratio (%) of Primary schools?
Offer a terse response. 1.7. What is the difference between the highest and the second highest Gross enrolment ratio (%) in Secondary schools?
Your response must be concise. 0.31. What is the difference between the highest and the second highest Gross enrolment ratio (%) in Tertiary schools?
Make the answer very short. 1.62. What is the difference between the highest and the lowest Gross enrolment ratio (%) of Pre-primary schools?
Offer a very short reply. 6.96. What is the difference between the highest and the lowest Gross enrolment ratio (%) of Primary schools?
Provide a succinct answer. 5.64. What is the difference between the highest and the lowest Gross enrolment ratio (%) of Secondary schools?
Your answer should be compact. 2.35. What is the difference between the highest and the lowest Gross enrolment ratio (%) in Tertiary schools?
Keep it short and to the point. 5.95. 